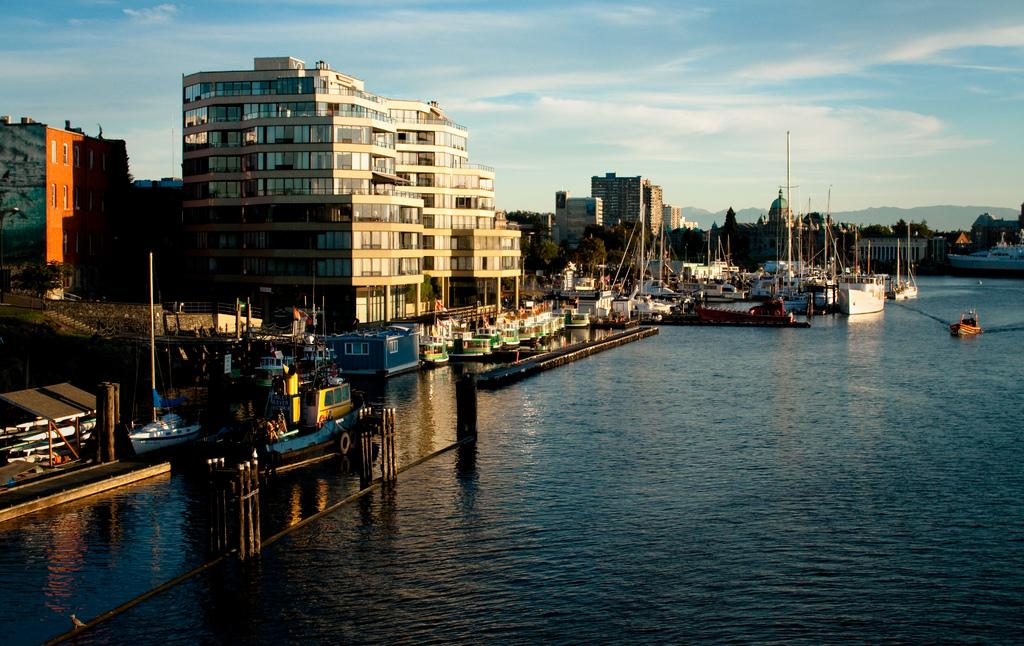What type of structures can be seen in the image? There are buildings in the image. What is visible at the bottom of the image? There is water visible at the bottom of the image. What type of vehicles are present in the image? There are boats in the image. What can be seen in the sky at the top of the image? There are clouds in the sky at the top of the image. What month is it in the image? The month cannot be determined from the image, as it does not contain any information about the time of year. What type of tank is visible in the image? There is no tank present in the image. 